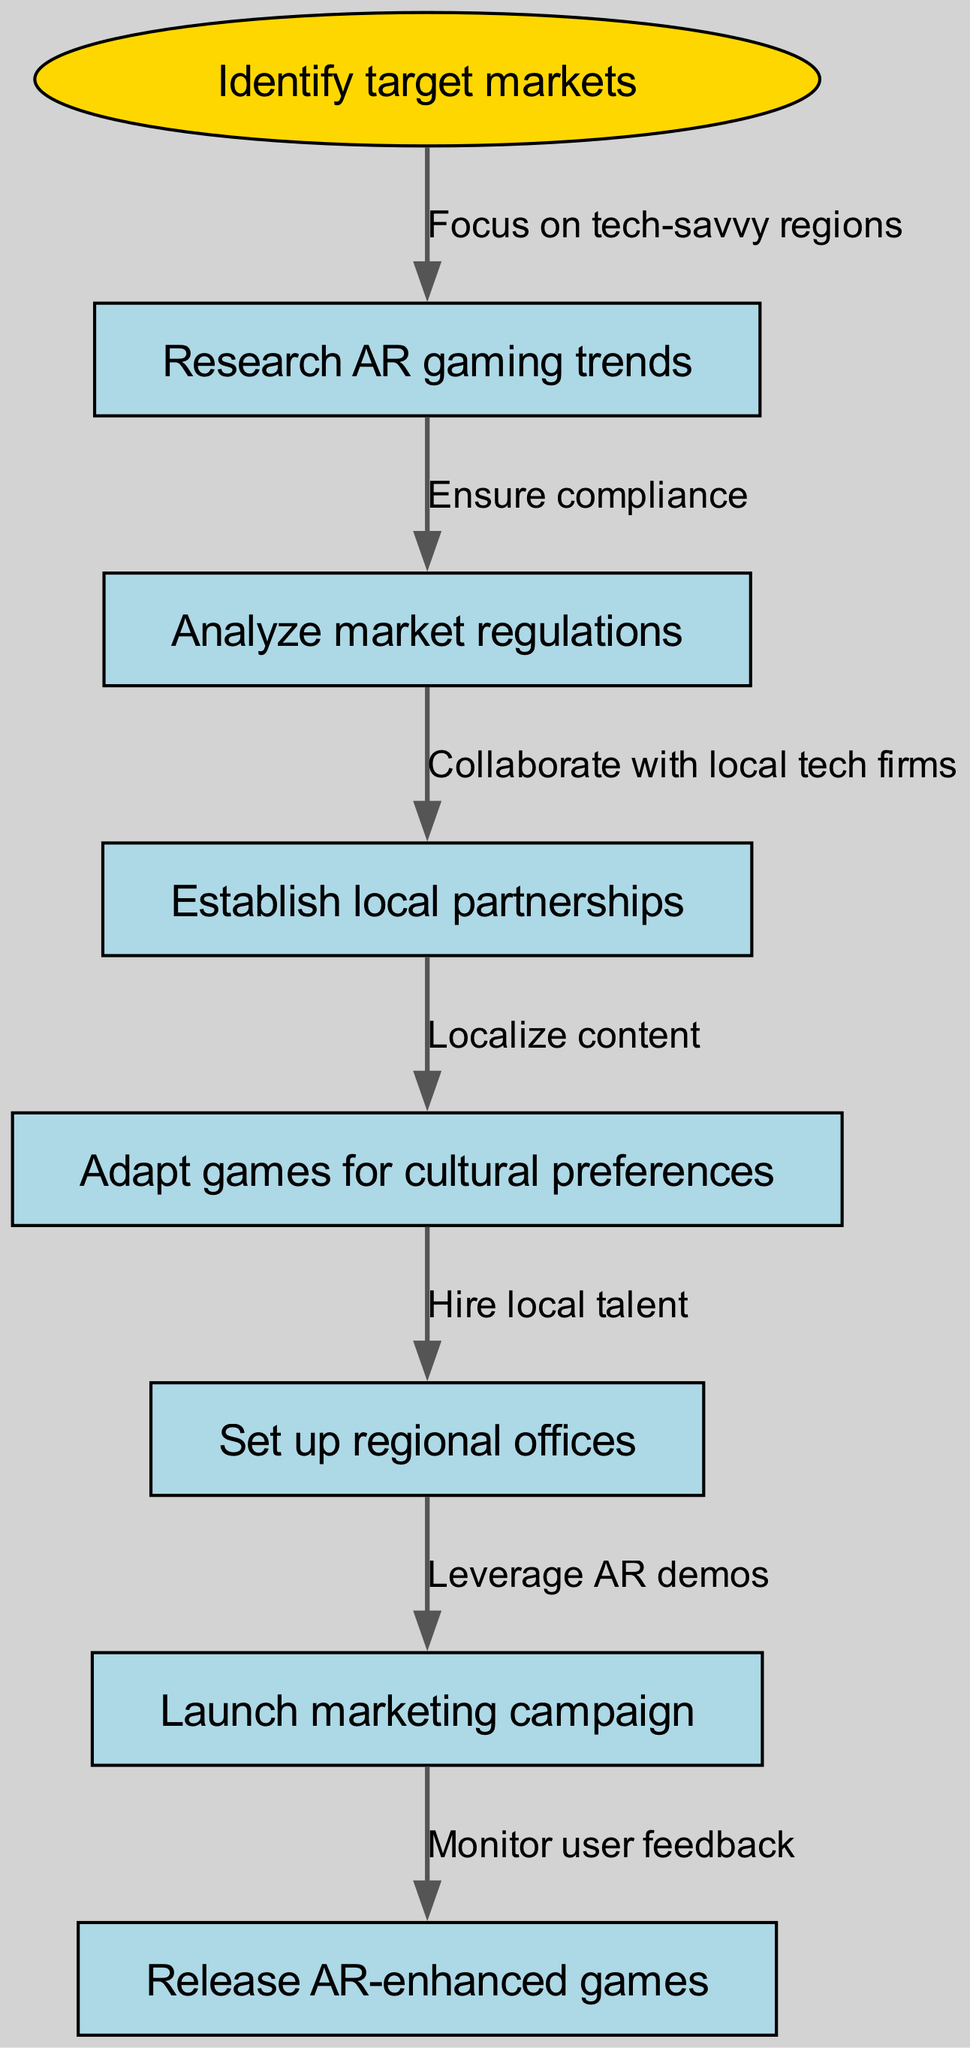What is the starting node of the flow chart? The flow chart begins at the node labeled "Identify target markets." This is specified in the data under the "startNode" key.
Answer: Identify target markets How many nodes are in the diagram? To find the number of nodes, we count the start node and all additional nodes present in the diagram. There is one start node and six additional regular nodes, totaling seven nodes.
Answer: 7 What is the relationship between "Research AR gaming trends" and "Analyze market regulations"? The relationship is defined by an edge that indicates "Research AR gaming trends" leads to "Analyze market regulations," with the label "Ensure compliance," showing the purpose of this connection.
Answer: Ensure compliance What comes after "Set up regional offices"? Following "Set up regional offices," the next node is "Launch marketing campaign," indicating the subsequent action after establishing regional offices.
Answer: Launch marketing campaign Which node is linked to "Adapt games for cultural preferences"? The node that follows "Adapt games for cultural preferences" is linked and represented by "Set up regional offices," demonstrating the next step in the strategy.
Answer: Set up regional offices What is the total number of edges in the diagram? The total number of edges is counted by the connections between nodes. There are six connections represented in the data, showing the flow of actions taken.
Answer: 6 What node precedes "Release AR-enhanced games"? The node preceding "Release AR-enhanced games" is "Launch marketing campaign," indicating that the marketing phase comes before releasing the games.
Answer: Launch marketing campaign How does the strategy suggest adapting games? The strategy suggests adapting games by localizing content to match cultural preferences, as indicated in the connection from "Establish local partnerships" to "Adapt games for cultural preferences."
Answer: Localize content What is the purpose of establishing local partnerships? The purpose of establishing local partnerships is "Collaborate with local tech firms," which is the label on the edge that connects those two nodes, indicating the main goal of this step.
Answer: Collaborate with local tech firms 